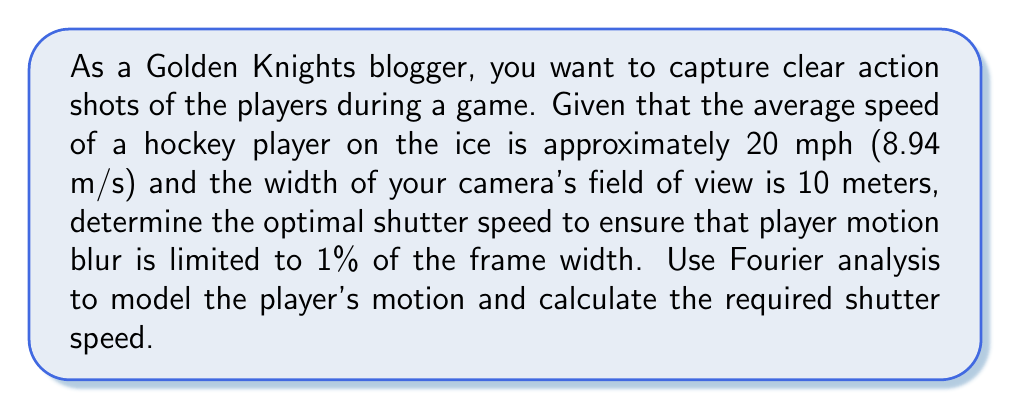Could you help me with this problem? To solve this problem, we'll use Fourier analysis to model the player's motion and determine the optimal shutter speed. Let's break it down step by step:

1) First, we need to consider the player's motion as a signal. In this case, it's a linear motion across the frame. We can model this as a rect function in the spatial domain.

2) The Fourier transform of a rect function is a sinc function in the frequency domain. The width of the main lobe of the sinc function is inversely proportional to the width of the rect function.

3) Let's define our variables:
   $v$ = player speed = 8.94 m/s
   $W$ = frame width = 10 m
   $b$ = allowed blur = 1% of frame width = 0.01W = 0.1 m

4) The time it takes for the player to cross the entire frame is:
   $$T = \frac{W}{v} = \frac{10}{8.94} \approx 1.12 \text{ seconds}$$

5) We want to limit the blur to 1% of the frame width. This means the player should move no more than 0.1 m during the exposure. The time for this movement is:
   $$t = \frac{b}{v} = \frac{0.1}{8.94} \approx 0.0112 \text{ seconds}$$

6) In the frequency domain, the width of the main lobe of the sinc function (which represents the motion blur) is approximately:
   $$\Delta f = \frac{1}{t} = \frac{1}{0.0112} \approx 89.4 \text{ Hz}$$

7) To capture this frequency without aliasing, according to the Nyquist-Shannon sampling theorem, we need to sample at least twice this frequency:
   $$f_s = 2\Delta f = 2 * 89.4 = 178.8 \text{ Hz}$$

8) The shutter speed is the inverse of this sampling frequency:
   $$\text{Shutter Speed} = \frac{1}{f_s} = \frac{1}{178.8} \approx 0.0056 \text{ seconds}$$

Therefore, the optimal shutter speed to capture clear hockey action shots with minimal motion blur is approximately 1/179 second or 0.0056 seconds.
Answer: The optimal shutter speed is approximately $\frac{1}{179}$ second or 0.0056 seconds. 